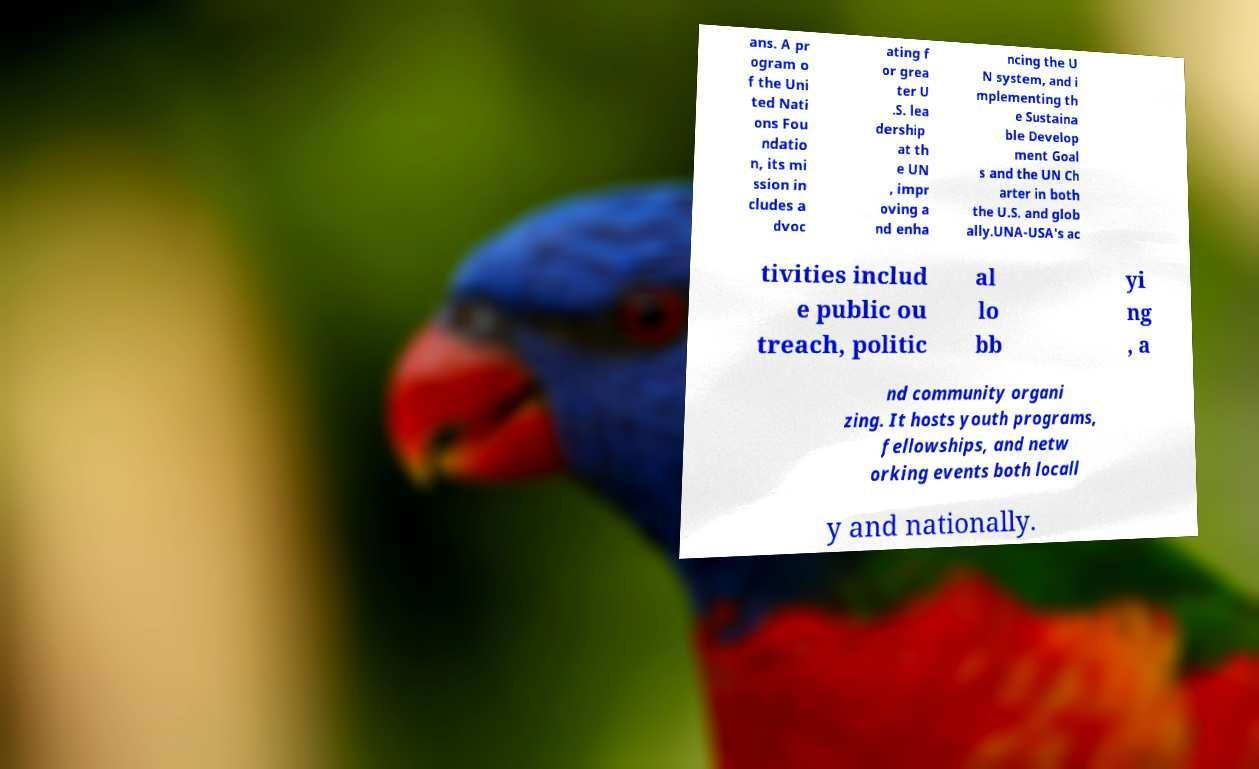There's text embedded in this image that I need extracted. Can you transcribe it verbatim? ans. A pr ogram o f the Uni ted Nati ons Fou ndatio n, its mi ssion in cludes a dvoc ating f or grea ter U .S. lea dership at th e UN , impr oving a nd enha ncing the U N system, and i mplementing th e Sustaina ble Develop ment Goal s and the UN Ch arter in both the U.S. and glob ally.UNA-USA's ac tivities includ e public ou treach, politic al lo bb yi ng , a nd community organi zing. It hosts youth programs, fellowships, and netw orking events both locall y and nationally. 